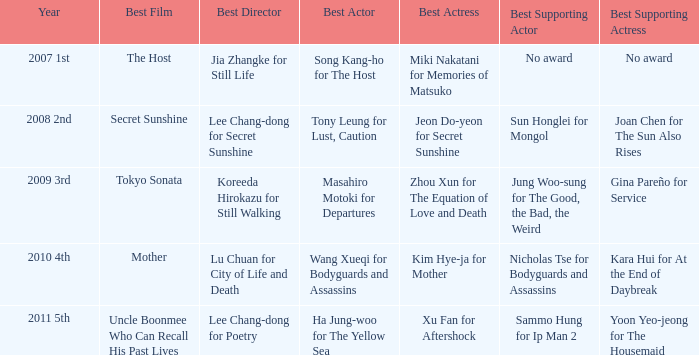Name the best supporting actress for sun honglei for mongol Joan Chen for The Sun Also Rises. 